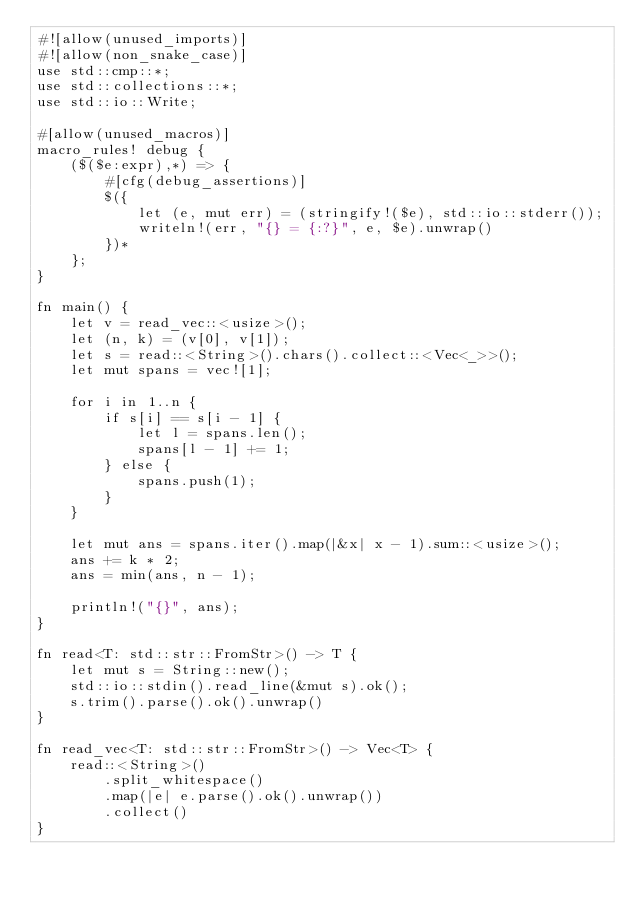<code> <loc_0><loc_0><loc_500><loc_500><_Rust_>#![allow(unused_imports)]
#![allow(non_snake_case)]
use std::cmp::*;
use std::collections::*;
use std::io::Write;

#[allow(unused_macros)]
macro_rules! debug {
    ($($e:expr),*) => {
        #[cfg(debug_assertions)]
        $({
            let (e, mut err) = (stringify!($e), std::io::stderr());
            writeln!(err, "{} = {:?}", e, $e).unwrap()
        })*
    };
}

fn main() {
    let v = read_vec::<usize>();
    let (n, k) = (v[0], v[1]);
    let s = read::<String>().chars().collect::<Vec<_>>();
    let mut spans = vec![1];

    for i in 1..n {
        if s[i] == s[i - 1] {
            let l = spans.len();
            spans[l - 1] += 1;
        } else {
            spans.push(1);
        }
    }

    let mut ans = spans.iter().map(|&x| x - 1).sum::<usize>();
    ans += k * 2;
    ans = min(ans, n - 1);

    println!("{}", ans);
}

fn read<T: std::str::FromStr>() -> T {
    let mut s = String::new();
    std::io::stdin().read_line(&mut s).ok();
    s.trim().parse().ok().unwrap()
}

fn read_vec<T: std::str::FromStr>() -> Vec<T> {
    read::<String>()
        .split_whitespace()
        .map(|e| e.parse().ok().unwrap())
        .collect()
}
</code> 